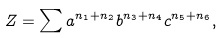<formula> <loc_0><loc_0><loc_500><loc_500>Z = \sum a ^ { n _ { 1 } + n _ { 2 } } b ^ { n _ { 3 } + n _ { 4 } } c ^ { n _ { 5 } + n _ { 6 } } ,</formula> 